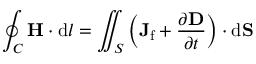<formula> <loc_0><loc_0><loc_500><loc_500>\oint _ { C } H \cdot d { l } = \iint _ { S } \left ( J _ { f } + { \frac { \partial D } { \partial t } } \right ) \cdot d S</formula> 